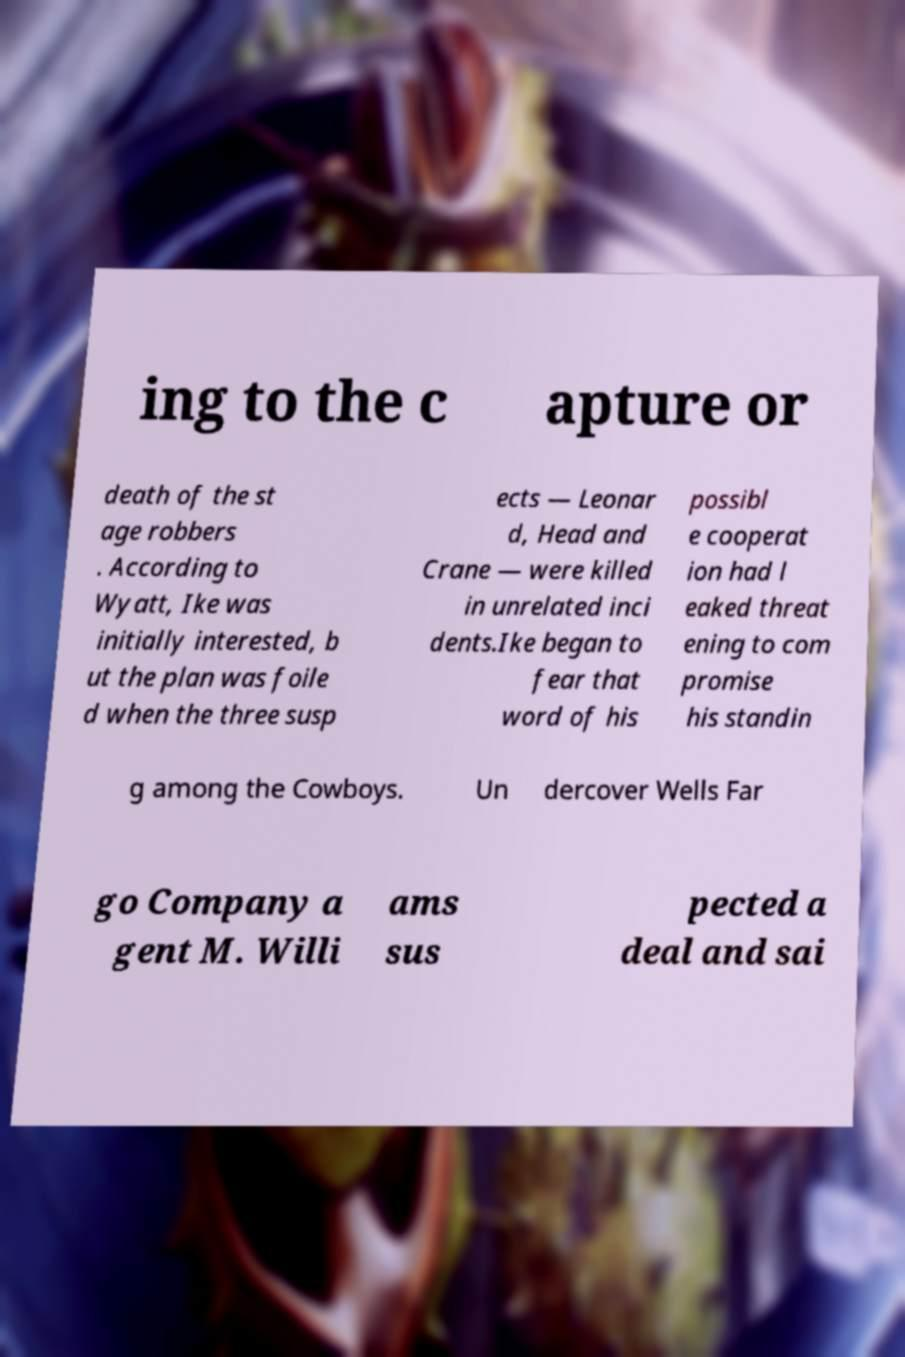Can you accurately transcribe the text from the provided image for me? ing to the c apture or death of the st age robbers . According to Wyatt, Ike was initially interested, b ut the plan was foile d when the three susp ects — Leonar d, Head and Crane — were killed in unrelated inci dents.Ike began to fear that word of his possibl e cooperat ion had l eaked threat ening to com promise his standin g among the Cowboys. Un dercover Wells Far go Company a gent M. Willi ams sus pected a deal and sai 